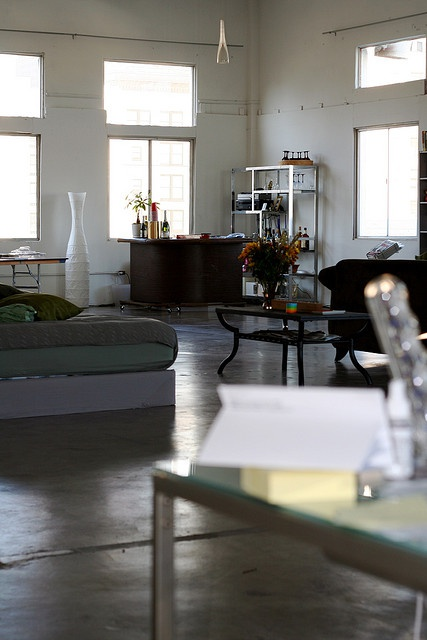Describe the objects in this image and their specific colors. I can see bed in gray and black tones, vase in gray, darkgray, and lightgray tones, potted plant in gray, white, darkgray, and tan tones, vase in gray, black, brown, and darkgray tones, and vase in gray, darkgray, and black tones in this image. 